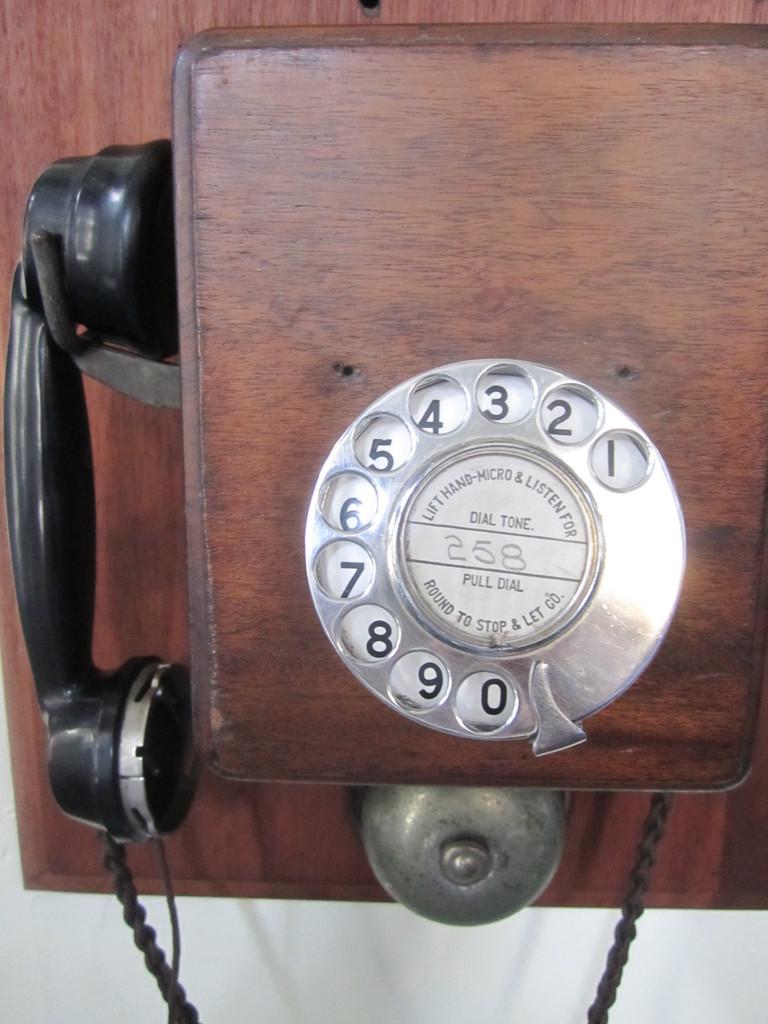What is the thing in the middle?
Provide a short and direct response. 258. 